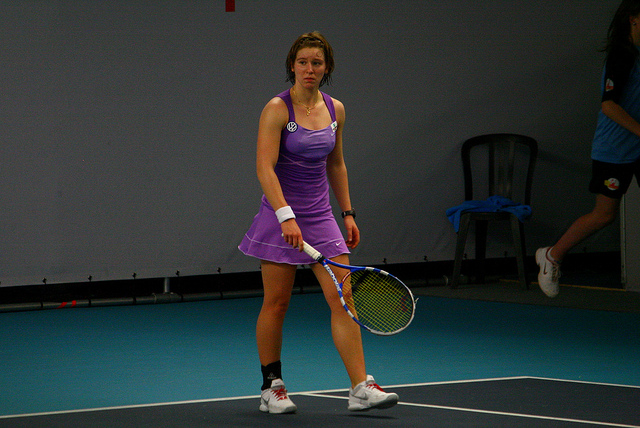<image>What brand shoes is the girl wearing? I am not sure what brand shoes the girl is wearing. However, it might be Nike. What famous tennis player is this? It is unknown which famous tennis player is in the image. It could be Chris Evert, Sophie Mestach, Martina, Anna, or Serena Williams. What brand shoes is the girl wearing? The girl is wearing Nike shoes. What famous tennis player is this? I don't know who is the famous tennis player in the image. 